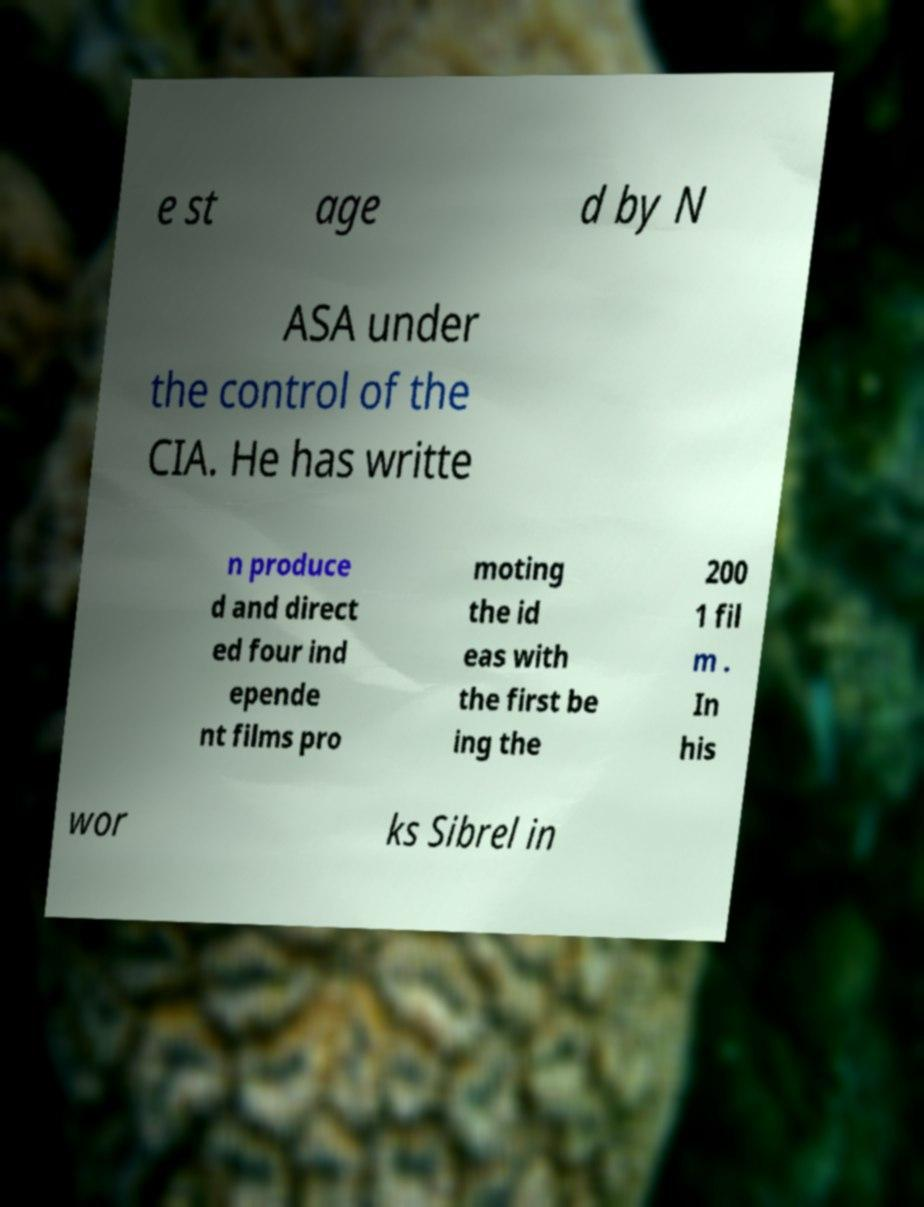Please identify and transcribe the text found in this image. e st age d by N ASA under the control of the CIA. He has writte n produce d and direct ed four ind epende nt films pro moting the id eas with the first be ing the 200 1 fil m . In his wor ks Sibrel in 